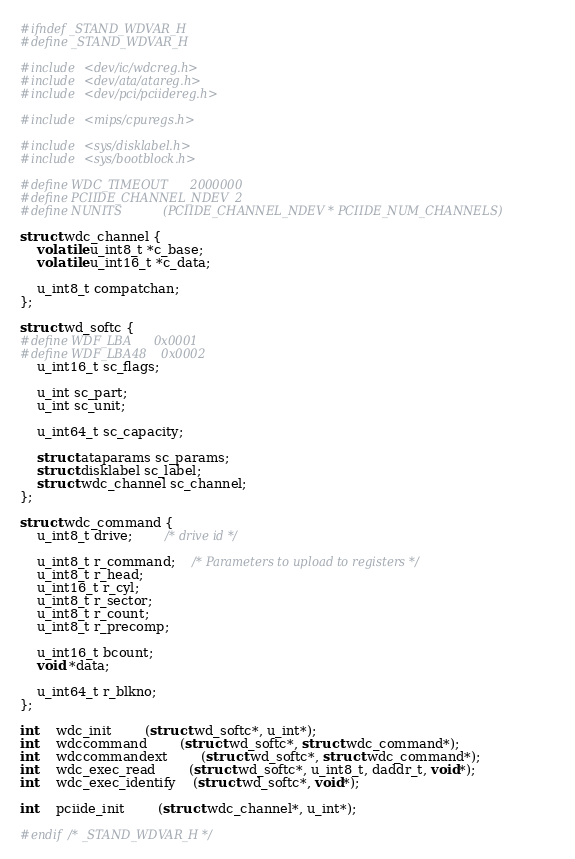<code> <loc_0><loc_0><loc_500><loc_500><_C_>
#ifndef _STAND_WDVAR_H
#define _STAND_WDVAR_H

#include <dev/ic/wdcreg.h>
#include <dev/ata/atareg.h>
#include <dev/pci/pciidereg.h>

#include <mips/cpuregs.h>

#include <sys/disklabel.h>
#include <sys/bootblock.h>

#define WDC_TIMEOUT		2000000
#define PCIIDE_CHANNEL_NDEV	2
#define NUNITS			(PCIIDE_CHANNEL_NDEV * PCIIDE_NUM_CHANNELS)

struct wdc_channel {
	volatile u_int8_t *c_base;
	volatile u_int16_t *c_data;

	u_int8_t compatchan;
};

struct wd_softc {
#define WDF_LBA		0x0001
#define WDF_LBA48	0x0002
	u_int16_t sc_flags;

	u_int sc_part;
	u_int sc_unit;

	u_int64_t sc_capacity;

	struct ataparams sc_params;
	struct disklabel sc_label;
	struct wdc_channel sc_channel;
};

struct wdc_command {
	u_int8_t drive;		/* drive id */

	u_int8_t r_command;	/* Parameters to upload to registers */
	u_int8_t r_head;
	u_int16_t r_cyl;
	u_int8_t r_sector;
	u_int8_t r_count;
	u_int8_t r_precomp;

	u_int16_t bcount;
	void *data;

	u_int64_t r_blkno;
};

int	wdc_init		(struct wd_softc*, u_int*);
int	wdccommand		(struct wd_softc*, struct wdc_command*);
int	wdccommandext		(struct wd_softc*, struct wdc_command*);
int	wdc_exec_read		(struct wd_softc*, u_int8_t, daddr_t, void*);
int	wdc_exec_identify	(struct wd_softc*, void*);

int	pciide_init		(struct wdc_channel*, u_int*);

#endif /* _STAND_WDVAR_H */
</code> 